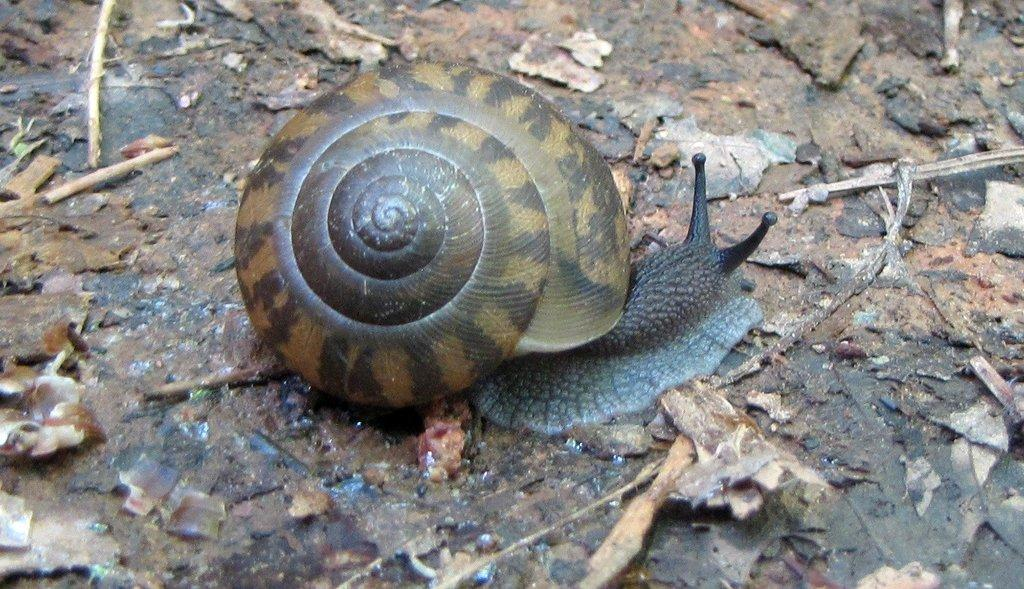What type of animal can be seen in the image? There is a snail in the image. What is present on the ground in the image? There are shredded leaves on the ground in the image. What type of knife is being used to cut the snail in the image? There is no knife present in the image, and the snail is not being cut. 